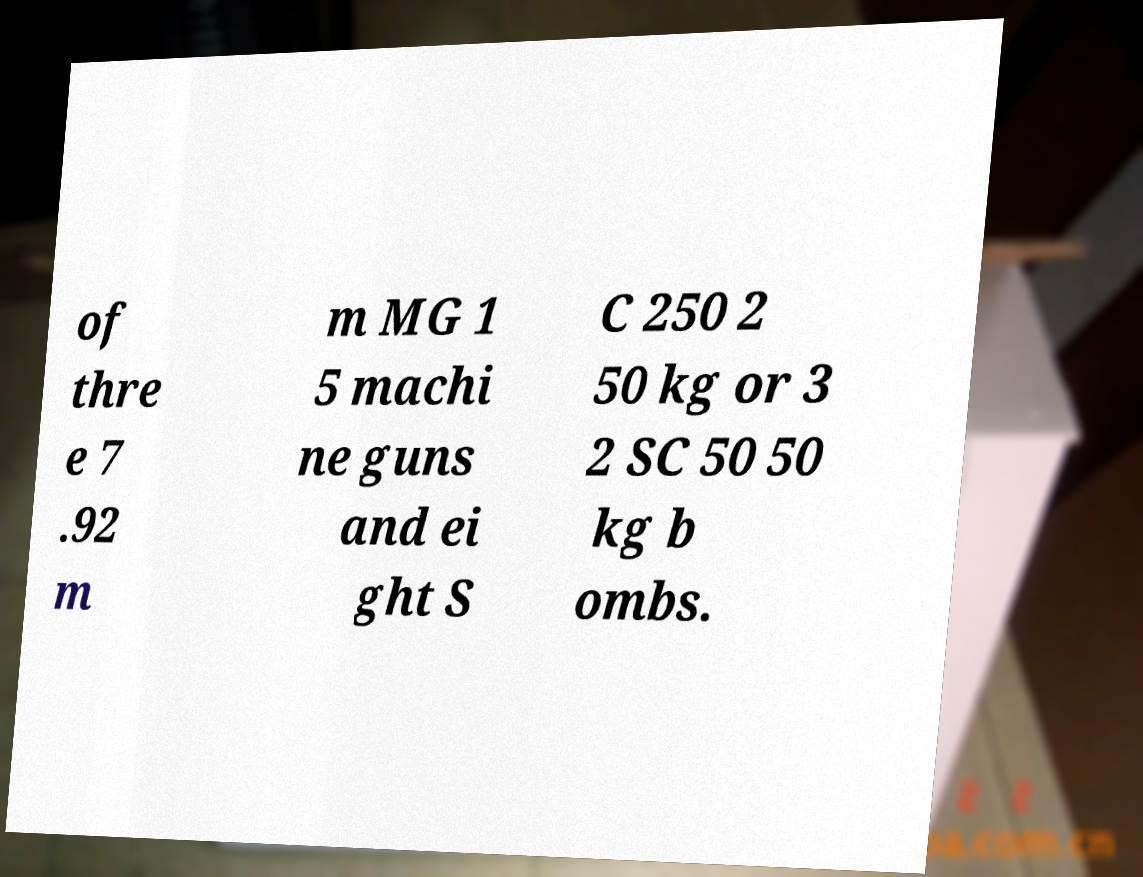What messages or text are displayed in this image? I need them in a readable, typed format. of thre e 7 .92 m m MG 1 5 machi ne guns and ei ght S C 250 2 50 kg or 3 2 SC 50 50 kg b ombs. 